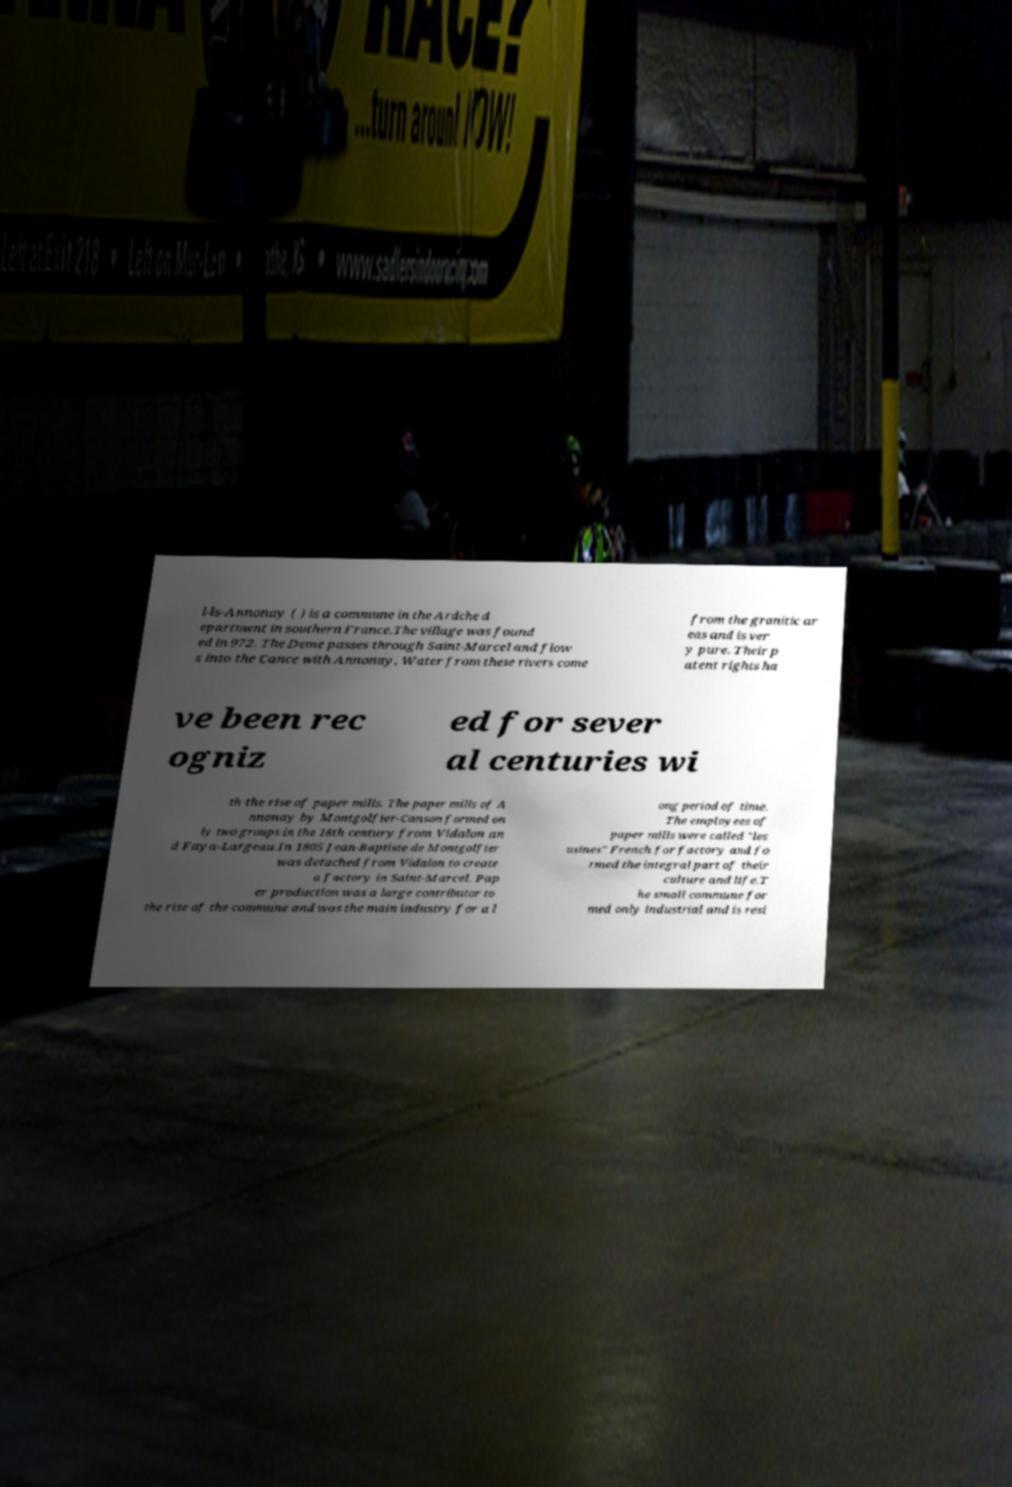Please read and relay the text visible in this image. What does it say? l-ls-Annonay ( ) is a commune in the Ardche d epartment in southern France.The village was found ed in 972. The Deme passes through Saint-Marcel and flow s into the Cance with Annonay. Water from these rivers come from the granitic ar eas and is ver y pure. Their p atent rights ha ve been rec ogniz ed for sever al centuries wi th the rise of paper mills. The paper mills of A nnonay by Montgolfier-Canson formed on ly two groups in the 18th century from Vidalon an d Faya-Largeau.In 1805 Jean-Baptiste de Montgolfier was detached from Vidalon to create a factory in Saint-Marcel. Pap er production was a large contributor to the rise of the commune and was the main industry for a l ong period of time. The employees of paper mills were called "les usines" French for factory and fo rmed the integral part of their culture and life.T he small commune for med only industrial and is resi 